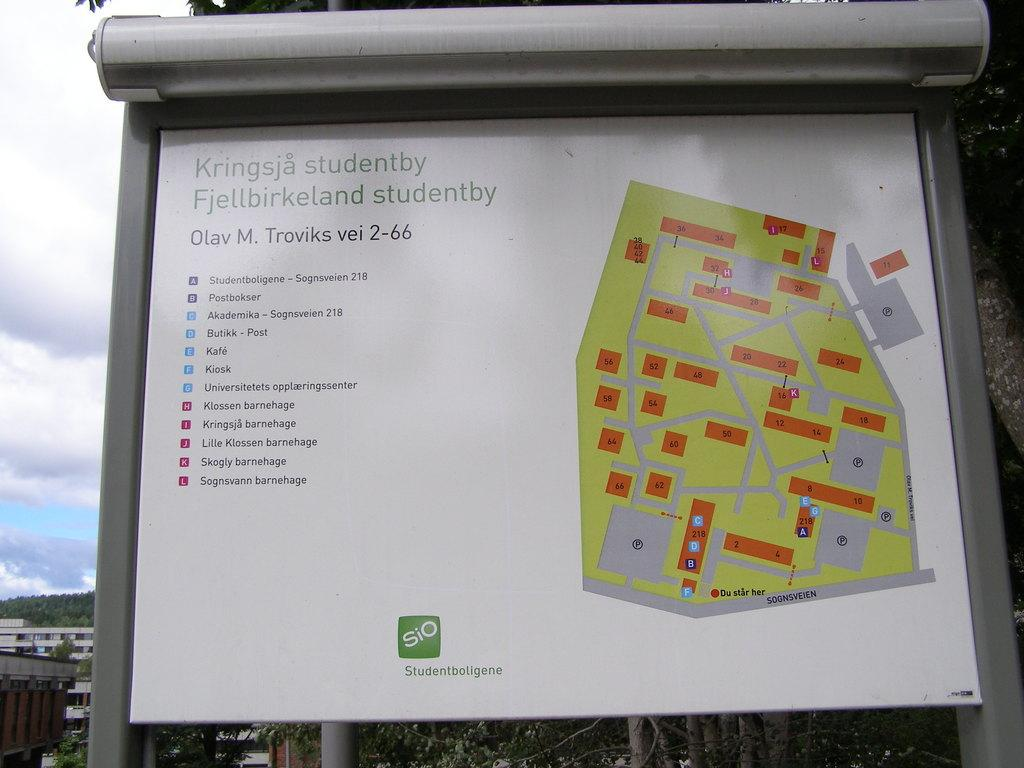Provide a one-sentence caption for the provided image. A map billboard for Kringsja studentby Fjellbirkeland studentby. 